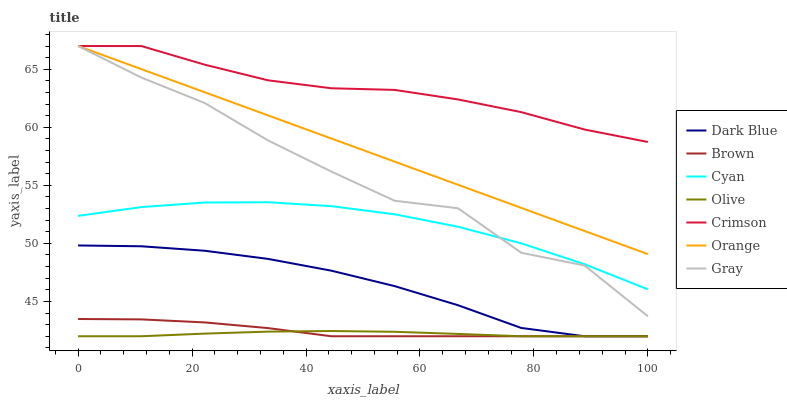Does Olive have the minimum area under the curve?
Answer yes or no. Yes. Does Crimson have the maximum area under the curve?
Answer yes or no. Yes. Does Gray have the minimum area under the curve?
Answer yes or no. No. Does Gray have the maximum area under the curve?
Answer yes or no. No. Is Orange the smoothest?
Answer yes or no. Yes. Is Gray the roughest?
Answer yes or no. Yes. Is Dark Blue the smoothest?
Answer yes or no. No. Is Dark Blue the roughest?
Answer yes or no. No. Does Brown have the lowest value?
Answer yes or no. Yes. Does Gray have the lowest value?
Answer yes or no. No. Does Orange have the highest value?
Answer yes or no. Yes. Does Dark Blue have the highest value?
Answer yes or no. No. Is Dark Blue less than Crimson?
Answer yes or no. Yes. Is Gray greater than Dark Blue?
Answer yes or no. Yes. Does Brown intersect Dark Blue?
Answer yes or no. Yes. Is Brown less than Dark Blue?
Answer yes or no. No. Is Brown greater than Dark Blue?
Answer yes or no. No. Does Dark Blue intersect Crimson?
Answer yes or no. No. 